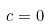<formula> <loc_0><loc_0><loc_500><loc_500>c = 0</formula> 